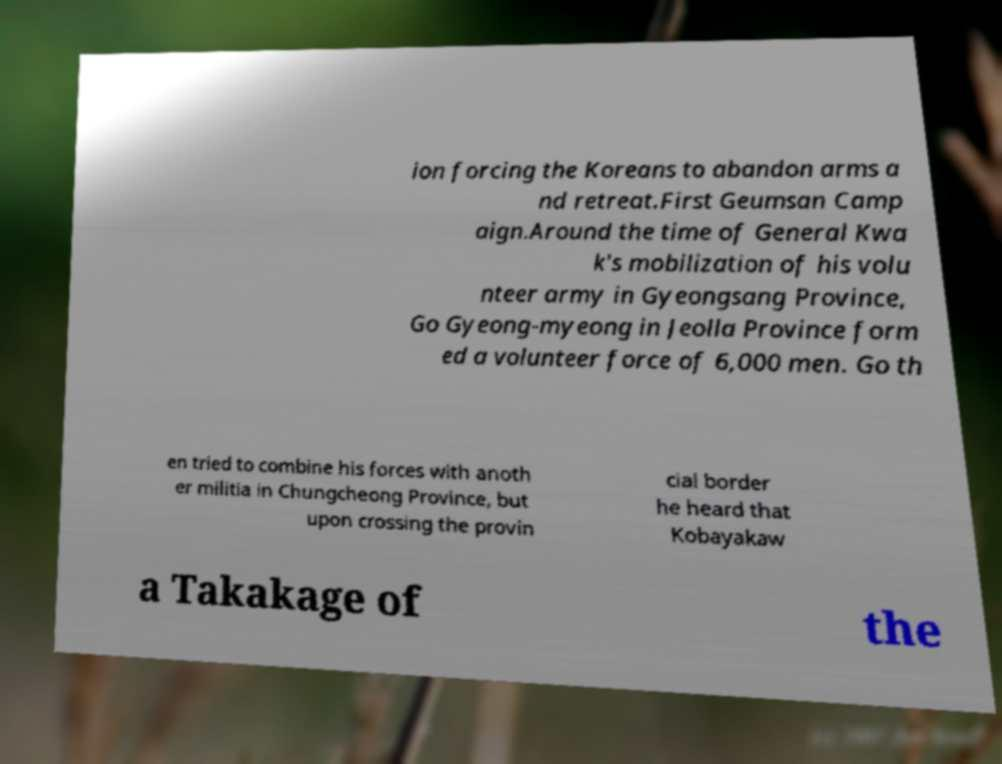Can you read and provide the text displayed in the image?This photo seems to have some interesting text. Can you extract and type it out for me? ion forcing the Koreans to abandon arms a nd retreat.First Geumsan Camp aign.Around the time of General Kwa k's mobilization of his volu nteer army in Gyeongsang Province, Go Gyeong-myeong in Jeolla Province form ed a volunteer force of 6,000 men. Go th en tried to combine his forces with anoth er militia in Chungcheong Province, but upon crossing the provin cial border he heard that Kobayakaw a Takakage of the 